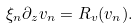Convert formula to latex. <formula><loc_0><loc_0><loc_500><loc_500>\xi _ { n } \partial _ { z } v _ { n } = R _ { v } ( v _ { n } ) .</formula> 